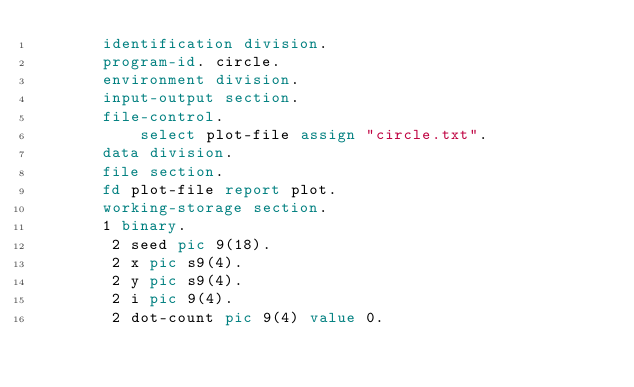Convert code to text. <code><loc_0><loc_0><loc_500><loc_500><_COBOL_>       identification division.
       program-id. circle.
       environment division.
       input-output section.
       file-control.
           select plot-file assign "circle.txt".
       data division.
       file section.
       fd plot-file report plot.
       working-storage section.
       1 binary.
        2 seed pic 9(18).
        2 x pic s9(4).
        2 y pic s9(4).
        2 i pic 9(4).
        2 dot-count pic 9(4) value 0.</code> 